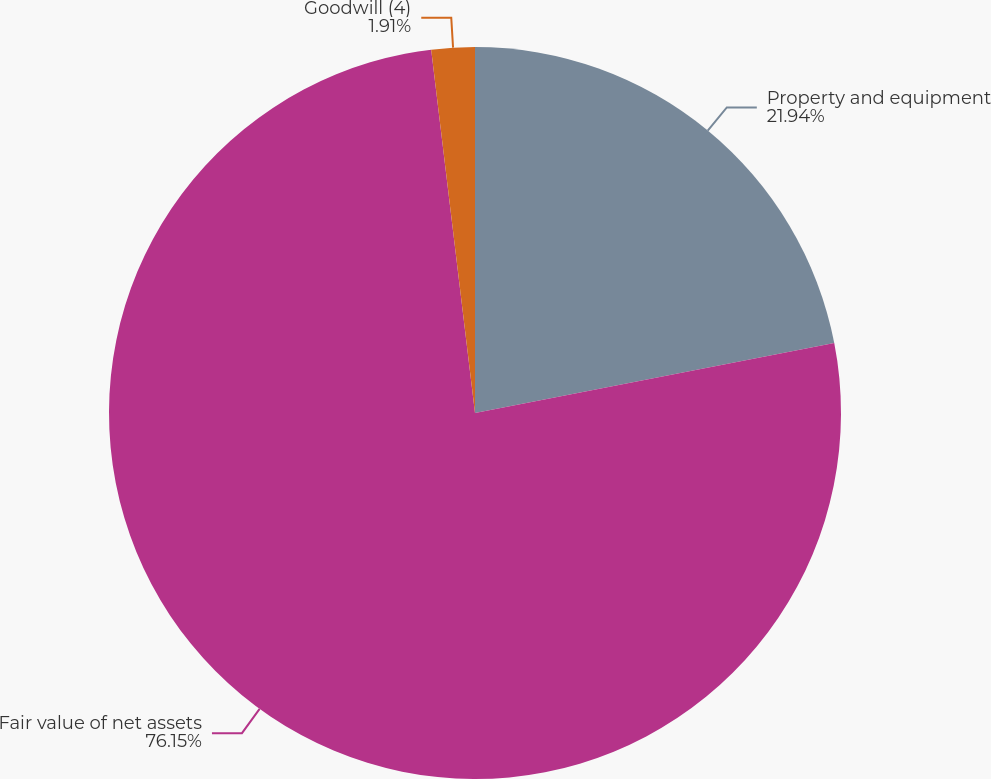Convert chart. <chart><loc_0><loc_0><loc_500><loc_500><pie_chart><fcel>Property and equipment<fcel>Fair value of net assets<fcel>Goodwill (4)<nl><fcel>21.94%<fcel>76.16%<fcel>1.91%<nl></chart> 